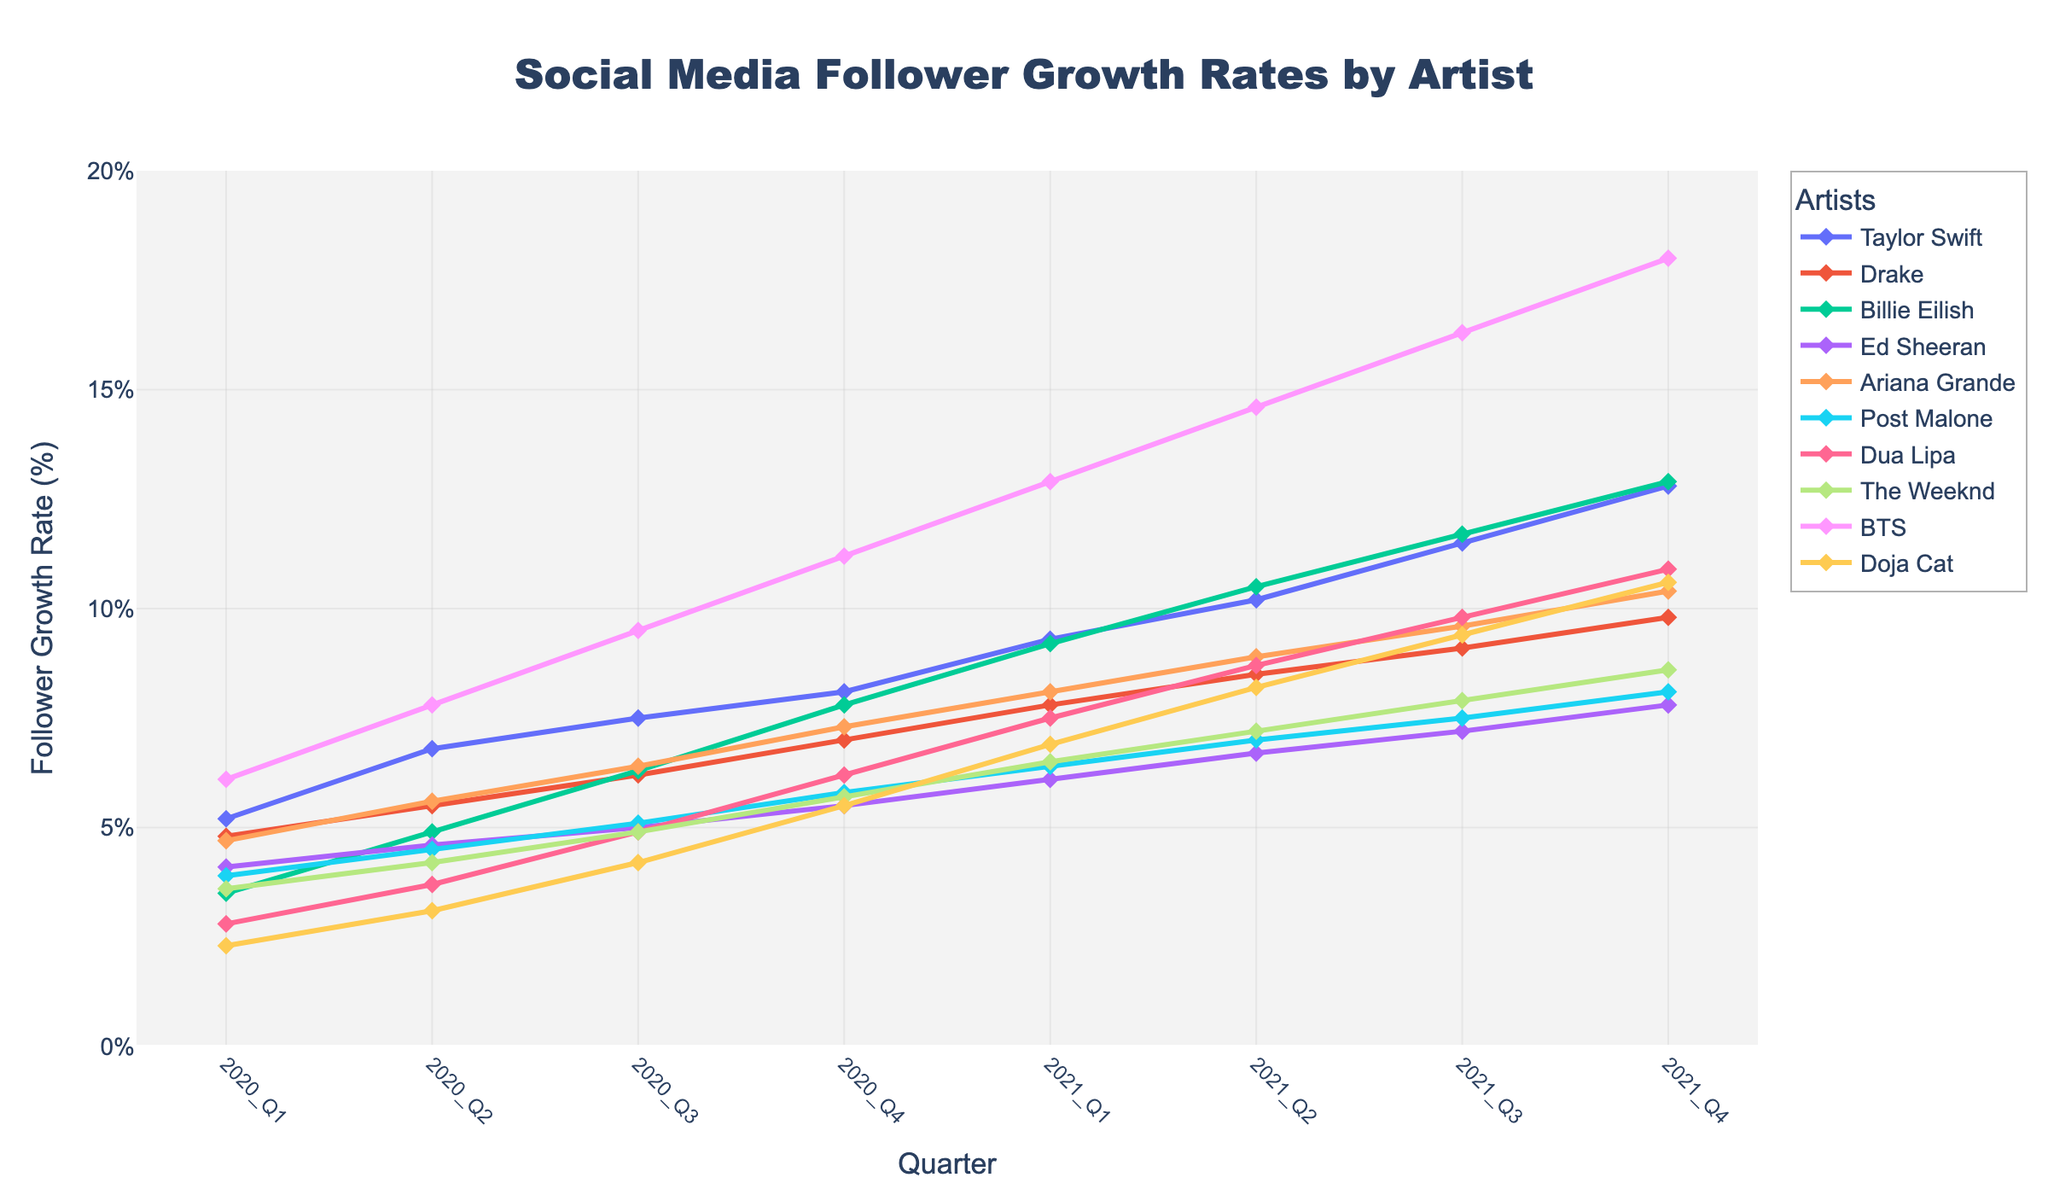What is the follower growth rate for BTS in 2021 Q4? Look for the value at the 2021 Q4 point on BTS's line in the chart.
Answer: 18.0% Which artist had the highest growth rate in 2020 Q3 and what was the rate? Compare the 2020 Q3 values across all artists and identify the highest one.
Answer: BTS, 9.5% How much did Taylor Swift's follower growth rate increase from 2020 Q1 to 2021 Q1? Subtract the 2020 Q1 value for Taylor Swift from her 2021 Q1 value.
Answer: 4.1% Who had a higher growth rate in 2021 Q3, Billie Eilish or Dua Lipa? Compare the 2021 Q3 values for Billie Eilish and Dua Lipa.
Answer: Billie Eilish What is the average follower growth rate for Taylor Swift in 2020? Add Taylor Swift's growth rates for all 2020 quarters and divide by 4.
Answer: 6.9% By how much did The Weeknd's follower growth rate change from 2020 Q2 to 2021 Q4? Subtract The Weeknd's 2020 Q2 value from his 2021 Q4 value.
Answer: 4.4% Which age group, 18-24 or 25-34, had the highest average follower growth rate in 2021 Q4? Calculate the average 2021 Q4 value for artists in each age group and compare them.
Answer: 25-34 How did Drake's follower growth rate change from 2020 Q4 to 2021 Q4? Subtract the 2020 Q4 value for Drake from his 2021 Q4 value.
Answer: 2.8% For the artists in the Hip-Hop genre, what was the total follower growth rate for 2021 Q2? Add the 2021 Q2 values for all artists in the Hip-Hop genre.
Answer: 23.7% Which artist saw the least change in follower growth rate from 2020 Q1 to 2021 Q4? Find the smallest difference between the 2020 Q1 and 2021 Q4 values across all artists.
Answer: The Weeknd 